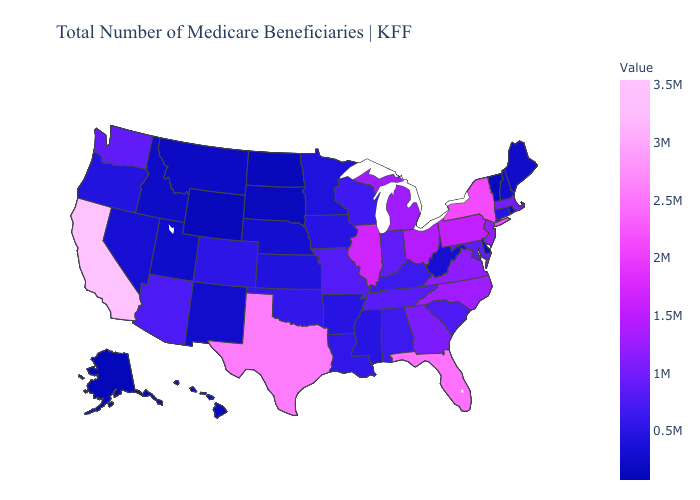Among the states that border Kentucky , which have the highest value?
Give a very brief answer. Illinois. Does Indiana have a higher value than Ohio?
Be succinct. No. Among the states that border Massachusetts , does New Hampshire have the highest value?
Concise answer only. No. Does the map have missing data?
Short answer required. No. Does California have the highest value in the USA?
Keep it brief. Yes. Does Illinois have the highest value in the MidWest?
Answer briefly. Yes. 